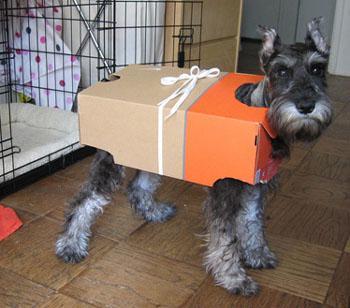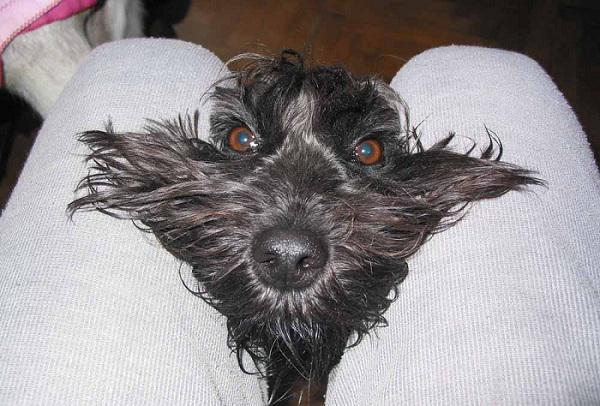The first image is the image on the left, the second image is the image on the right. Assess this claim about the two images: "The dog in the image on the right is standing on two legs.". Correct or not? Answer yes or no. No. The first image is the image on the left, the second image is the image on the right. For the images displayed, is the sentence "At least one schnauzer is in front of a white wall in a balancing upright pose, with its front paws not supported by anything." factually correct? Answer yes or no. No. 